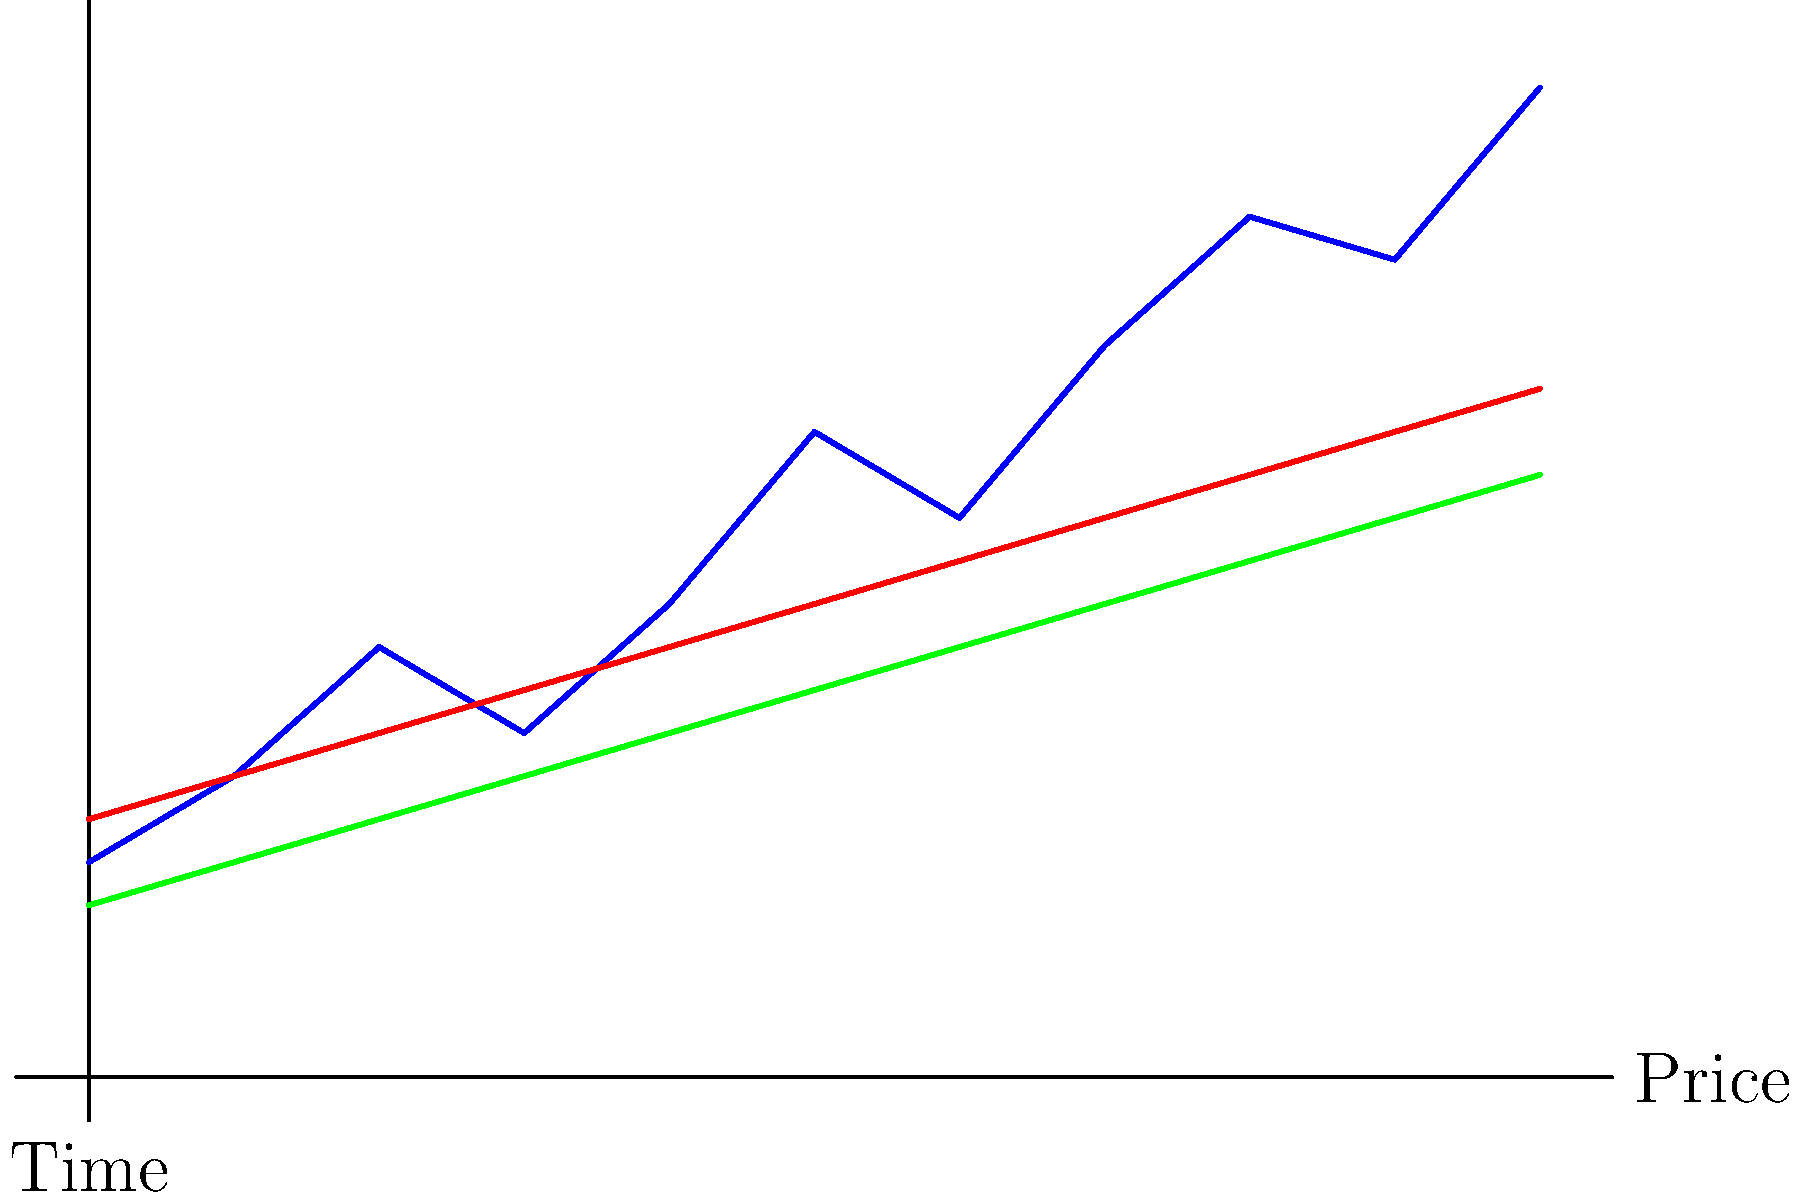As a portfolio manager, you're analyzing a stock's price chart with 50-day and 200-day moving averages (MA). What technical signal is generated when the 50-day MA crosses above the 200-day MA, and what action would you typically consider based on this information? To answer this question, let's break down the analysis step-by-step:

1. Identify the moving averages:
   - The red line represents the 50-day moving average (MA)
   - The green line represents the 200-day moving average (MA)

2. Observe the crossover:
   - At the beginning of the chart, the 50-day MA is below the 200-day MA
   - As we move to the right, the 50-day MA crosses above the 200-day MA

3. Recognize the technical signal:
   - When the shorter-term MA (50-day) crosses above the longer-term MA (200-day), this is known as a "Golden Cross"
   - The Golden Cross is generally considered a bullish signal in technical analysis

4. Interpret the signal:
   - A Golden Cross suggests a potential long-term uptrend in the stock price
   - It indicates that recent price action (represented by the 50-day MA) is becoming more positive than the longer-term trend (200-day MA)

5. Consider potential actions:
   - As a portfolio manager, you might consider increasing exposure to this stock
   - This could involve:
     a) Initiating a new long position if you don't already own the stock
     b) Adding to an existing position if you already have exposure
     c) Adjusting your overall portfolio allocation to give more weight to this stock

6. Additional considerations:
   - While the Golden Cross is a strong bullish signal, it should not be used in isolation
   - Consider other factors such as:
     a) Fundamental analysis of the company
     b) Overall market conditions
     c) Sector trends
     d) Risk management and diversification principles

By combining this technical signal with other analytical tools and your expertise as a portfolio manager, you can make a more informed decision about potential actions regarding this stock.
Answer: Golden Cross; consider increasing long exposure 